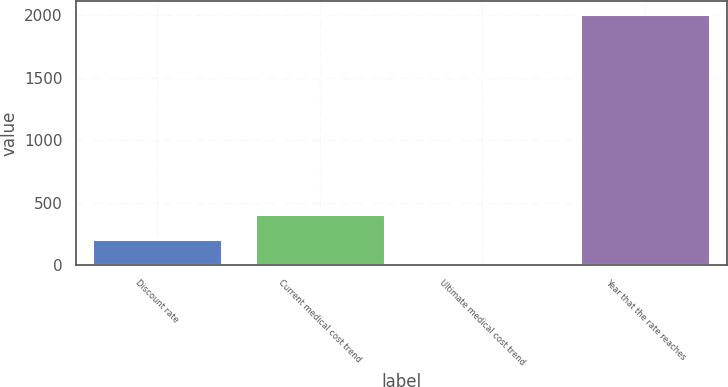<chart> <loc_0><loc_0><loc_500><loc_500><bar_chart><fcel>Discount rate<fcel>Current medical cost trend<fcel>Ultimate medical cost trend<fcel>Year that the rate reaches<nl><fcel>206<fcel>407<fcel>5<fcel>2015<nl></chart> 